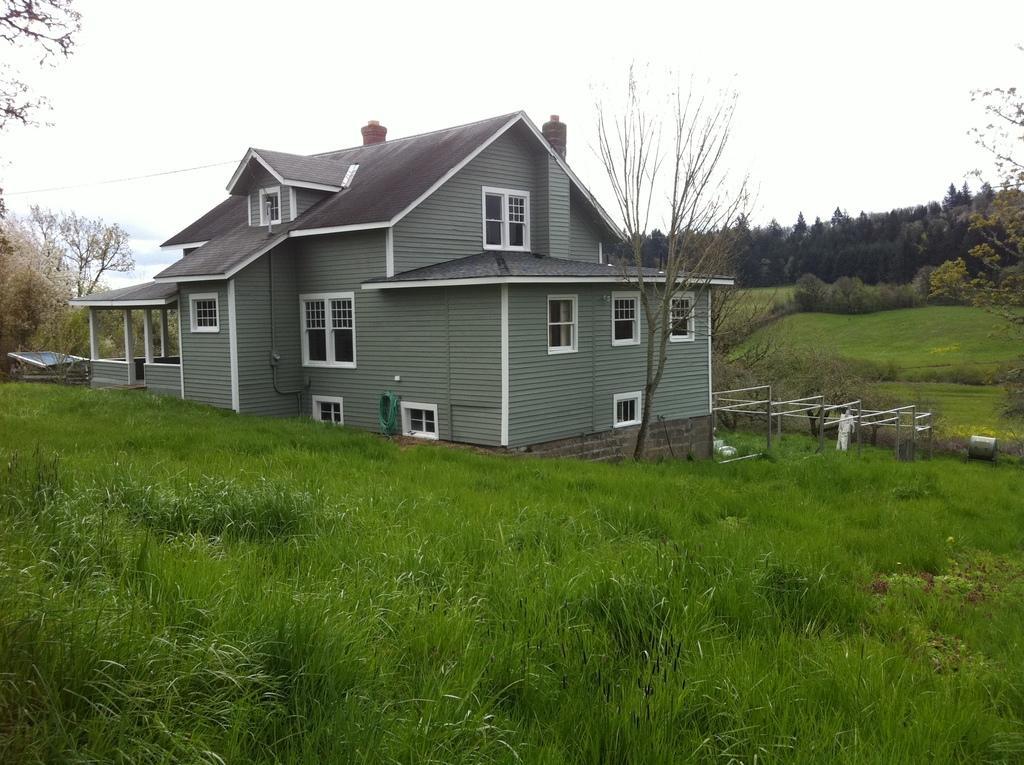In one or two sentences, can you explain what this image depicts? In the foreground of this image, there is a house and there is a grass around the house. On left, there are trees and on right, there are trees and grass. on top there is the sky. 